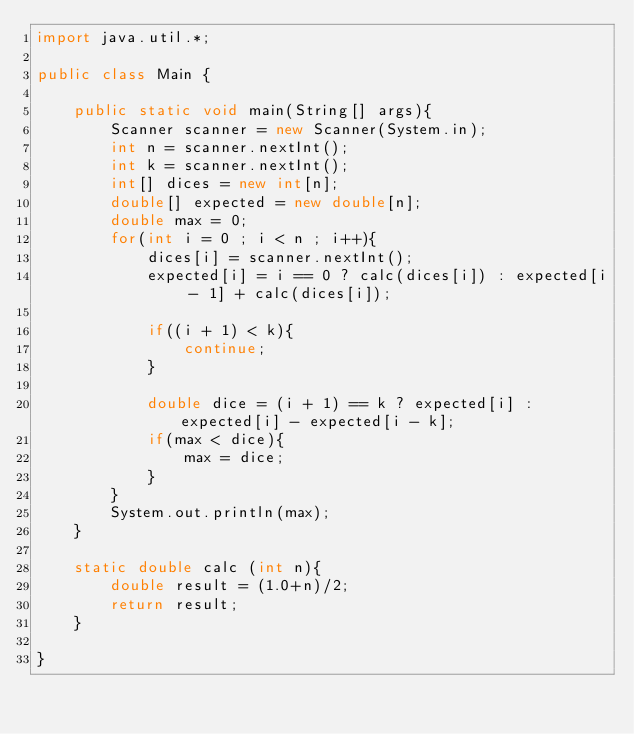<code> <loc_0><loc_0><loc_500><loc_500><_Java_>import java.util.*;

public class Main {

    public static void main(String[] args){
        Scanner scanner = new Scanner(System.in);
        int n = scanner.nextInt();
        int k = scanner.nextInt();
        int[] dices = new int[n];
        double[] expected = new double[n];
        double max = 0;
        for(int i = 0 ; i < n ; i++){
            dices[i] = scanner.nextInt();
            expected[i] = i == 0 ? calc(dices[i]) : expected[i - 1] + calc(dices[i]);

            if((i + 1) < k){
                continue;
            }

            double dice = (i + 1) == k ? expected[i] : expected[i] - expected[i - k];
            if(max < dice){
                max = dice;
            }
        }
        System.out.println(max);
    }

    static double calc (int n){
        double result = (1.0+n)/2;
        return result;
    }

}</code> 